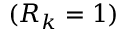Convert formula to latex. <formula><loc_0><loc_0><loc_500><loc_500>( R _ { k } = 1 )</formula> 